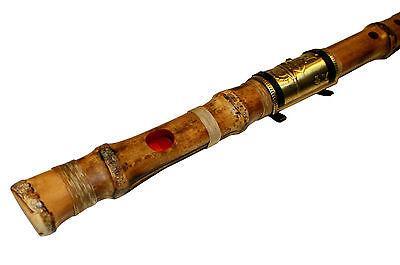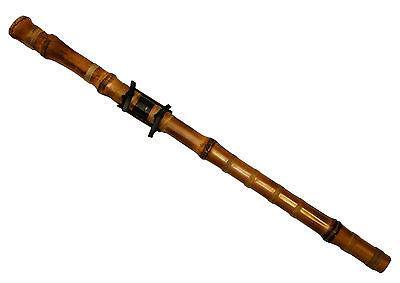The first image is the image on the left, the second image is the image on the right. Examine the images to the left and right. Is the description "Three or fewer flutes are visible." accurate? Answer yes or no. Yes. The first image is the image on the left, the second image is the image on the right. Evaluate the accuracy of this statement regarding the images: "There appears to be four flutes.". Is it true? Answer yes or no. No. 